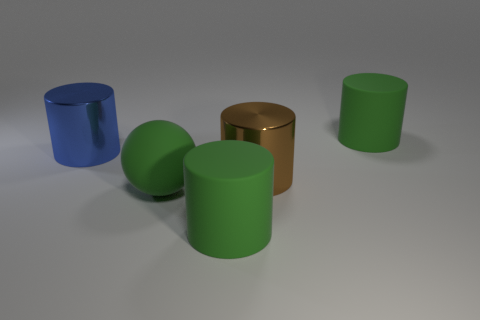Subtract all brown shiny cylinders. How many cylinders are left? 3 Subtract all spheres. How many objects are left? 4 Subtract all green cylinders. How many cylinders are left? 2 Subtract all red spheres. How many green cylinders are left? 2 Add 2 matte cylinders. How many objects exist? 7 Subtract all green rubber cylinders. Subtract all brown things. How many objects are left? 2 Add 2 large rubber cylinders. How many large rubber cylinders are left? 4 Add 1 big blue metallic things. How many big blue metallic things exist? 2 Subtract 0 green blocks. How many objects are left? 5 Subtract 2 cylinders. How many cylinders are left? 2 